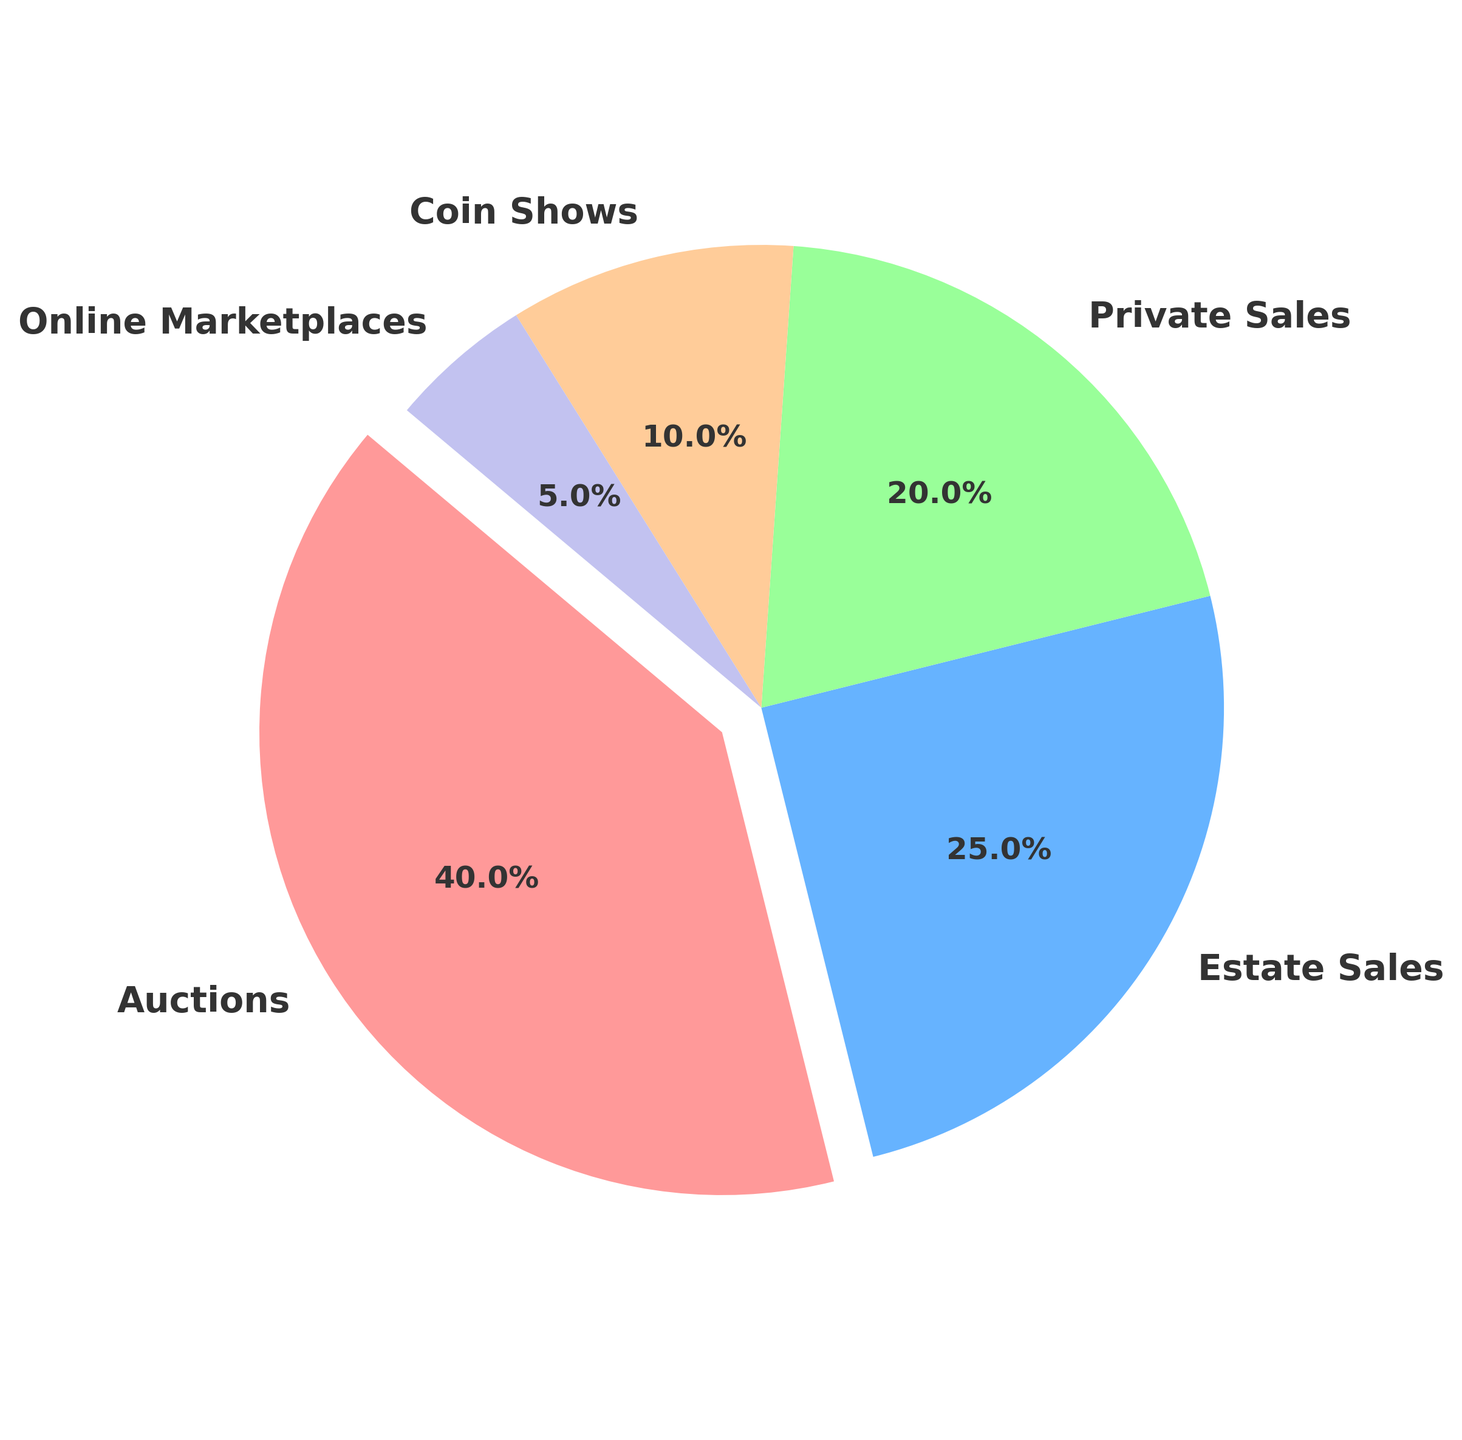What percentage of rare coins are acquired through Auctions and Estate Sales combined? First, note the percentages of Auctions (40%) and Estate Sales (25%) from the pie chart. Next, sum these two percentages: 40% + 25% = 65%.
Answer: 65% Which source accounts for the smallest percentage of rare coins acquired? From the pie chart, identify the smallest segment. Online Marketplaces have the lowest percentage at 5%.
Answer: Online Marketplaces Are Auctions responsible for acquiring more rare coins than Private Sales and Coin Shows combined? Compare the percentage of Auctions (40%) to the sum of Private Sales (20%) and Coin Shows (10%): 20% + 10% = 30%. Since 40% > 30%, Auctions acquire more coins.
Answer: Yes What is the difference in percentage between Estate Sales and Coin Shows? Identify the percentage for Estate Sales (25%) and Coin Shows (10%) from the pie chart, then calculate the difference: 25% - 10% = 15%.
Answer: 15% Which slice of the pie chart appears larger, Estate Sales or Private Sales? Visually inspect the pie chart to compare the sizes of the Estate Sales (25%) and Private Sales (20%) slices. Estate Sales is larger.
Answer: Estate Sales How much larger, in percentage points, is Auctions compared to Online Marketplaces? Note the percentage for Auctions (40%) and Online Marketplaces (5%). Subtract the smaller percentage from the larger one: 40% - 5% = 35%.
Answer: 35% If the total number of rare coins acquired is 1000, how many coins were acquired through Coin Shows? First, identify the percentage for Coin Shows (10%). Calculate the number of coins by multiplying 10% by 1000: 0.10 * 1000 = 100.
Answer: 100 Which methods collectively account for half of the total sources of rare coins? Find the cumulative percentage for methods until it reaches or exceeds 50%. Auctions (40%) + Estate Sales (25%) = 65%, which is over half. Thus, Auctions alone are more than half, or Auctions alone at 40% and partially Estate Sales.
Answer: Auctions and partially Estate Sales What is the median percentage value among the different sources of rare coins? Order the percentage values: 5%, 10%, 20%, 25%, 40%. The median is the middle value, which is 20%.
Answer: 20% What color represents the Auctions slice in the pie chart? Visually inspect the pie chart and identify the color of the slice labeled Auctions, which is the largest slice usually made distinctive. The color is typically red.
Answer: Red 